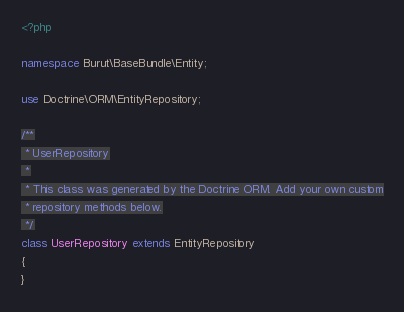<code> <loc_0><loc_0><loc_500><loc_500><_PHP_><?php

namespace Burut\BaseBundle\Entity;

use Doctrine\ORM\EntityRepository;

/**
 * UserRepository
 *
 * This class was generated by the Doctrine ORM. Add your own custom
 * repository methods below.
 */
class UserRepository extends EntityRepository
{
}
</code> 